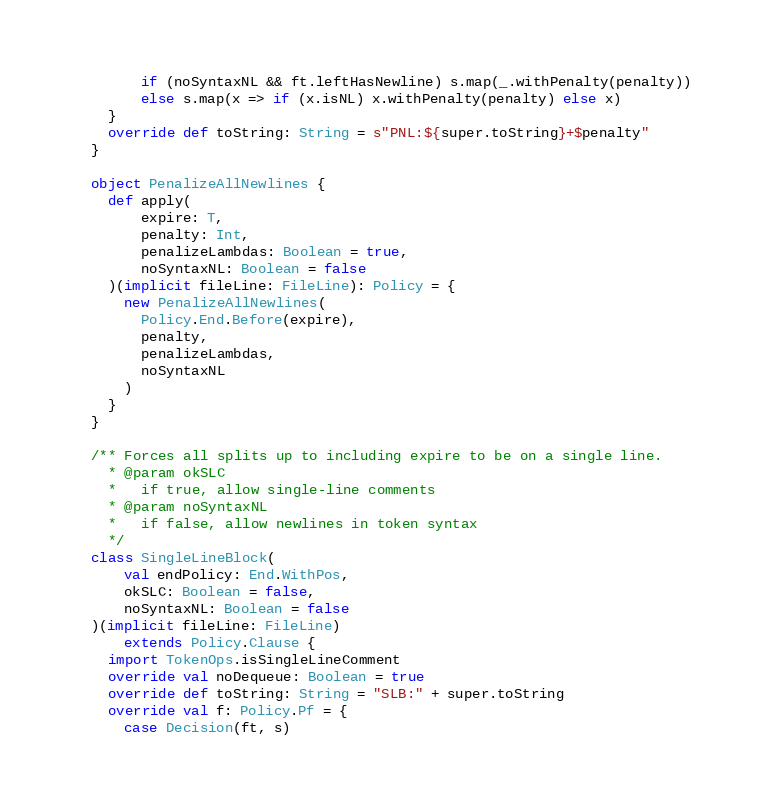<code> <loc_0><loc_0><loc_500><loc_500><_Scala_>        if (noSyntaxNL && ft.leftHasNewline) s.map(_.withPenalty(penalty))
        else s.map(x => if (x.isNL) x.withPenalty(penalty) else x)
    }
    override def toString: String = s"PNL:${super.toString}+$penalty"
  }

  object PenalizeAllNewlines {
    def apply(
        expire: T,
        penalty: Int,
        penalizeLambdas: Boolean = true,
        noSyntaxNL: Boolean = false
    )(implicit fileLine: FileLine): Policy = {
      new PenalizeAllNewlines(
        Policy.End.Before(expire),
        penalty,
        penalizeLambdas,
        noSyntaxNL
      )
    }
  }

  /** Forces all splits up to including expire to be on a single line.
    * @param okSLC
    *   if true, allow single-line comments
    * @param noSyntaxNL
    *   if false, allow newlines in token syntax
    */
  class SingleLineBlock(
      val endPolicy: End.WithPos,
      okSLC: Boolean = false,
      noSyntaxNL: Boolean = false
  )(implicit fileLine: FileLine)
      extends Policy.Clause {
    import TokenOps.isSingleLineComment
    override val noDequeue: Boolean = true
    override def toString: String = "SLB:" + super.toString
    override val f: Policy.Pf = {
      case Decision(ft, s)</code> 